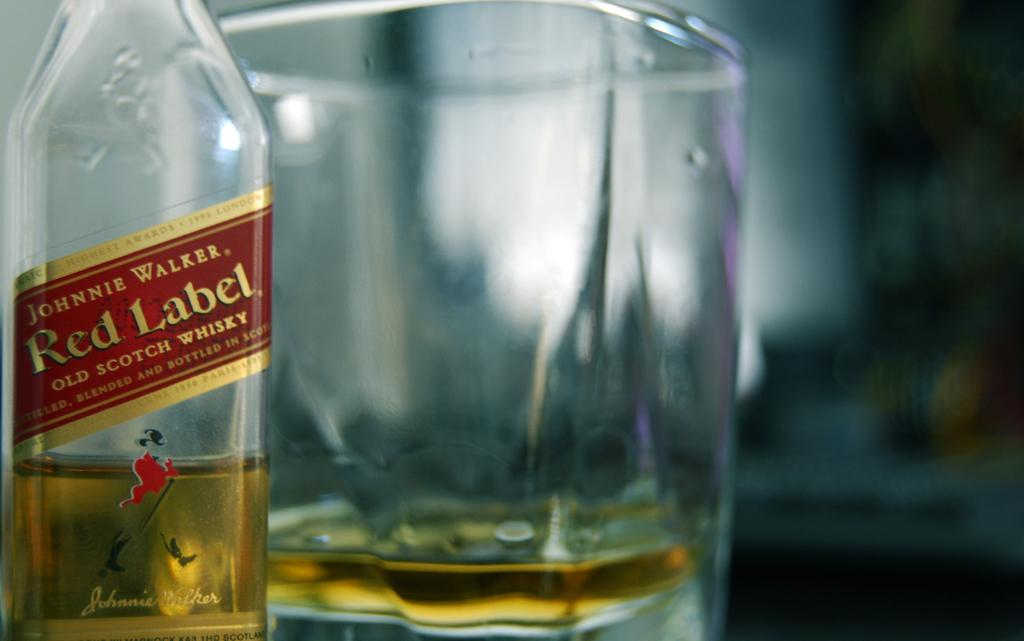Provide a one-sentence caption for the provided image. A glass of whiskey is served neat and is next to a bottle of Johnnie Walker Red. 